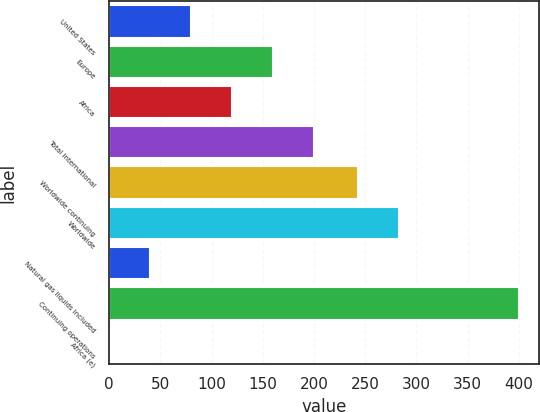<chart> <loc_0><loc_0><loc_500><loc_500><bar_chart><fcel>United States<fcel>Europe<fcel>Africa<fcel>Total International<fcel>Worldwide continuing<fcel>Worldwide<fcel>Natural gas liquids included<fcel>Continuing operations<fcel>Africa (e)<nl><fcel>80.2<fcel>160.16<fcel>120.18<fcel>200.13<fcel>243<fcel>282.98<fcel>40.23<fcel>400<fcel>0.25<nl></chart> 